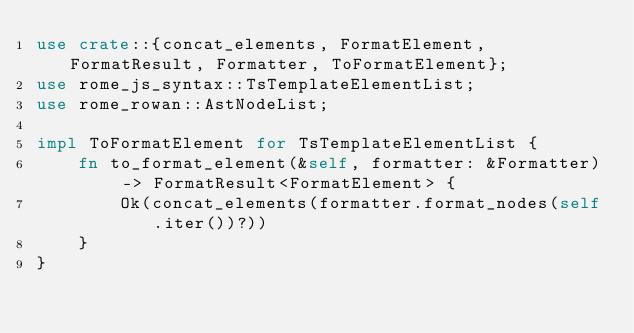<code> <loc_0><loc_0><loc_500><loc_500><_Rust_>use crate::{concat_elements, FormatElement, FormatResult, Formatter, ToFormatElement};
use rome_js_syntax::TsTemplateElementList;
use rome_rowan::AstNodeList;

impl ToFormatElement for TsTemplateElementList {
    fn to_format_element(&self, formatter: &Formatter) -> FormatResult<FormatElement> {
        Ok(concat_elements(formatter.format_nodes(self.iter())?))
    }
}
</code> 